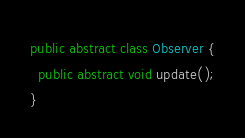Convert code to text. <code><loc_0><loc_0><loc_500><loc_500><_Java_>public abstract class Observer {
  public abstract void update();
}
</code> 